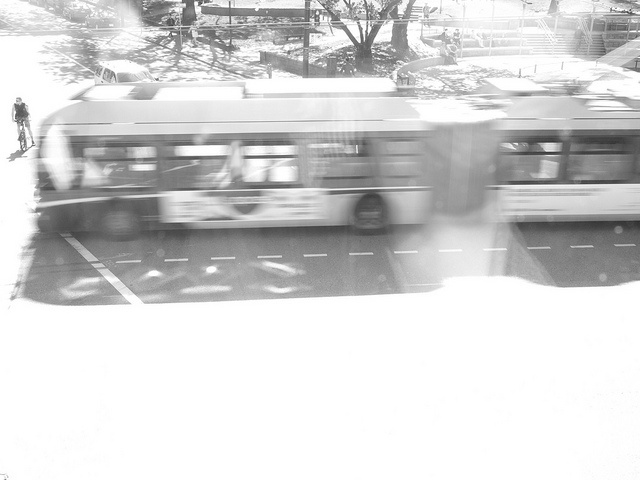Describe the objects in this image and their specific colors. I can see bus in white, lightgray, darkgray, gray, and black tones, bus in white, lightgray, gray, darkgray, and black tones, car in lightgray, darkgray, gray, and white tones, people in lightgray, darkgray, gray, and white tones, and people in lightgray, darkgray, and white tones in this image. 